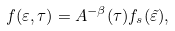Convert formula to latex. <formula><loc_0><loc_0><loc_500><loc_500>f ( \varepsilon , \tau ) = A ^ { - \beta } ( \tau ) f _ { s } ( \tilde { \varepsilon } ) ,</formula> 